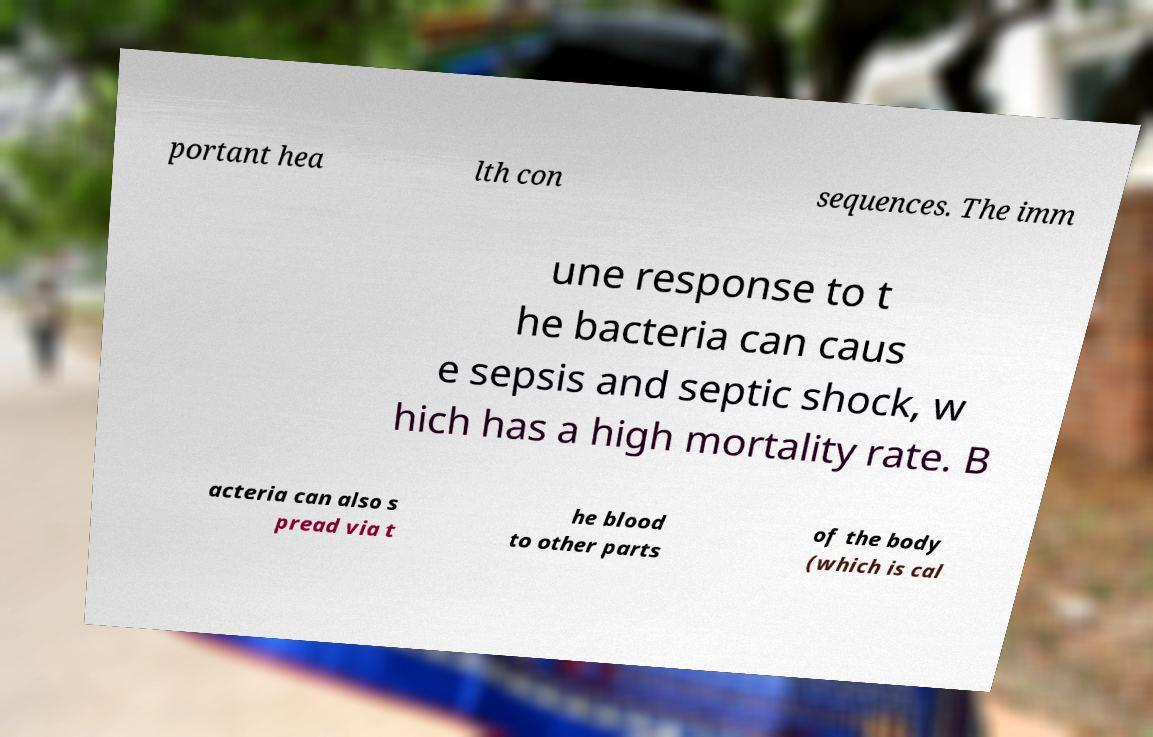I need the written content from this picture converted into text. Can you do that? portant hea lth con sequences. The imm une response to t he bacteria can caus e sepsis and septic shock, w hich has a high mortality rate. B acteria can also s pread via t he blood to other parts of the body (which is cal 